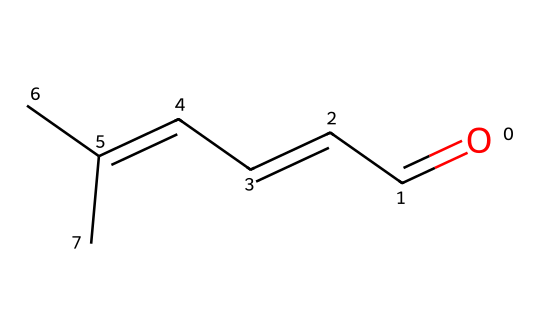What is the molecular formula of this compound? To determine the molecular formula, count the number of each type of atom in the SMILES representation. The structure shows five carbon atoms (C) and eight hydrogen atoms (H), yielding the formula C5H8.
Answer: C5H8 How many double bonds are present in this chemical? Examining the SMILES representation, there are two occurrences of "C=C," indicating the presence of two double bonds in the structure.
Answer: 2 What kind of hydrocarbon is represented by this chemical? This compound contains only carbon and hydrogen atoms, and it has double bonds, classifying it as an alkene.
Answer: alkene Is this compound likely to be solid at room temperature? Most alkenes are liquids at room temperature due to their lower molecular weights and types of intermolecular forces. Thus, it's unlikely to be solid.
Answer: unlikely What is the primary use of compounds similar to this in incense? Compounds like this one are often used in incense for their aromatic properties, providing fragrance and enhancing the olfactory experience in religious rituals.
Answer: fragrance Can you identify the functional group in this chemical? The presence of a carbonyl group (C=O) at one end of the chain indicates that this compound has an aldehyde functional group, which is characteristic of its structure.
Answer: aldehyde 